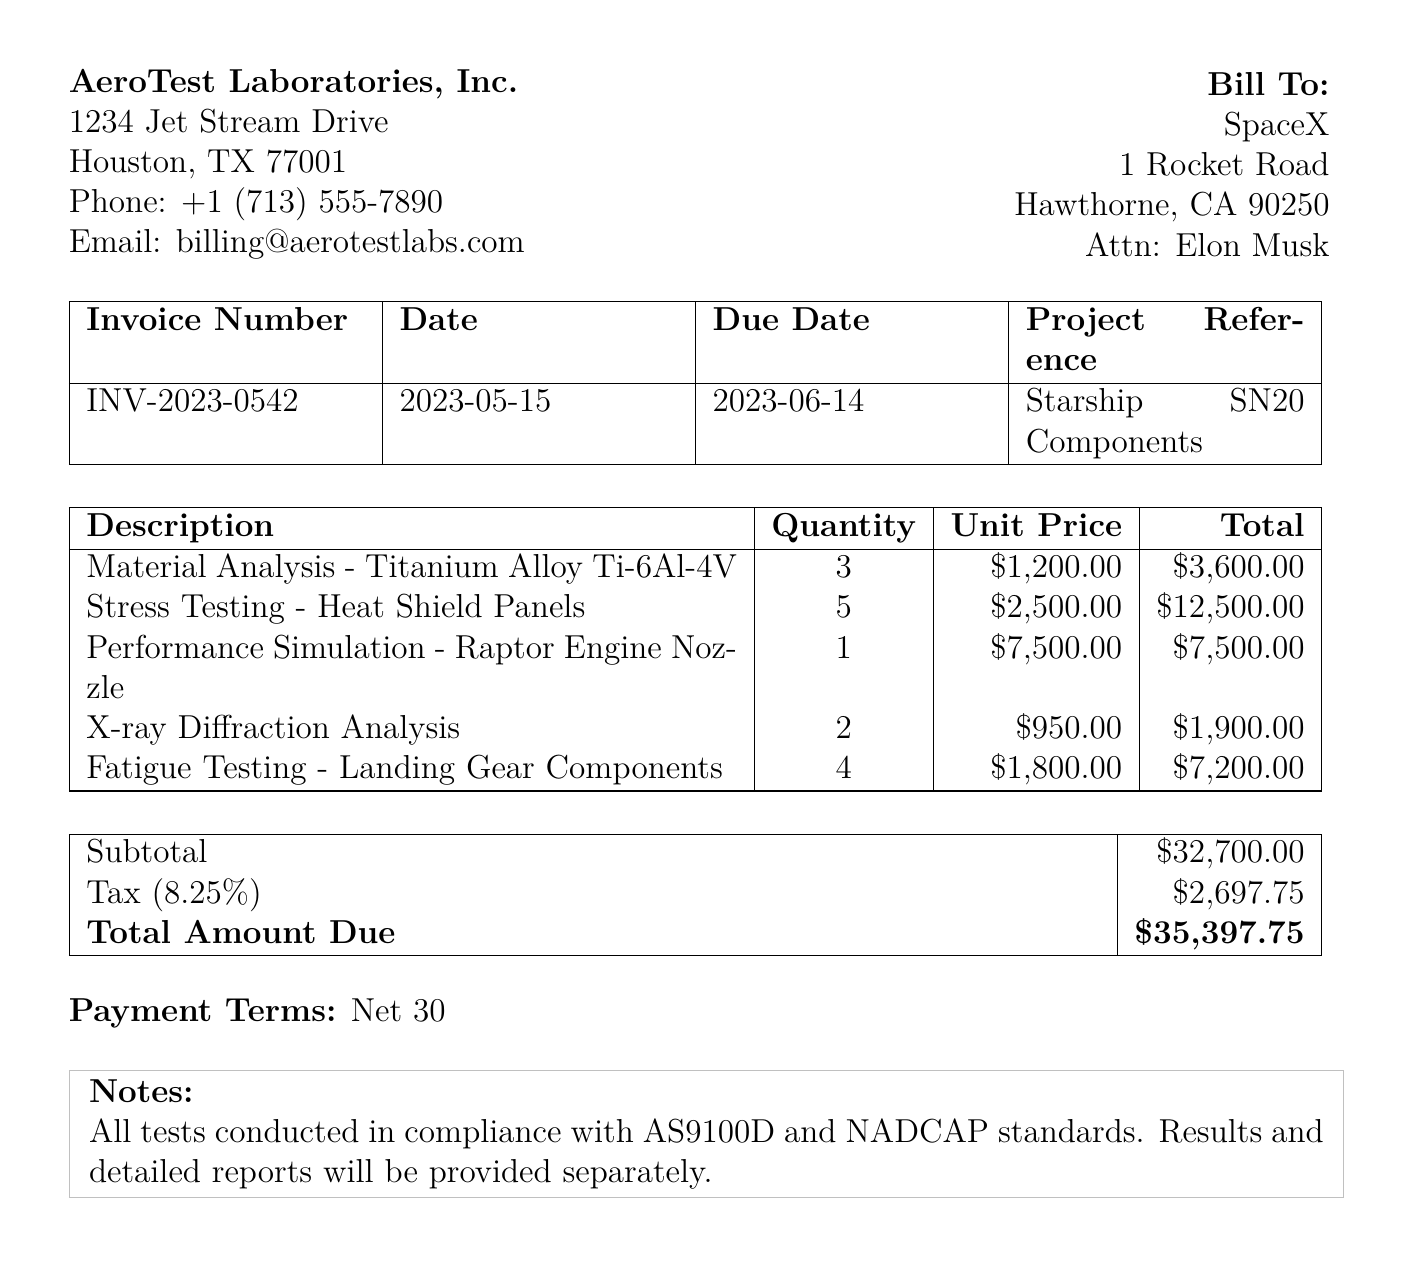What is the invoice number? The invoice number is specified in the document as a unique identifier for the billing statement, which is INV-2023-0542.
Answer: INV-2023-0542 What is the date of the invoice? The date of the invoice is provided to signify when the invoice was issued, which is May 15, 2023.
Answer: 2023-05-15 What is the total amount due? The total amount due is the final amount that needs to be paid, calculated as $35,397.75.
Answer: $35,397.75 How many units of stress testing were billed? The document specifies the quantity of stress testing units that were conducted, which is 5.
Answer: 5 What is the subtotal before tax? The subtotal represents the total cost of services before tax is applied, which is $32,700.00.
Answer: $32,700.00 What is the tax rate shown in the document? The tax rate is a percentage applied to the subtotal, which is 8.25%.
Answer: 8.25% What services are included in the total? The total reflects the combined cost of various services rendered, specifically material analysis, stress testing, performance simulation, X-ray diffraction analysis, and fatigue testing.
Answer: Material Analysis, Stress Testing, Performance Simulation, X-ray Diffraction Analysis, Fatigue Testing What is the payment term specified? The payment term indicates the period in which the invoice should be paid, which is Net 30.
Answer: Net 30 What laboratory is issuing this invoice? The issuing laboratory is identified in the document header to clarify who is billing for the services, which is AeroTest Laboratories, Inc.
Answer: AeroTest Laboratories, Inc 